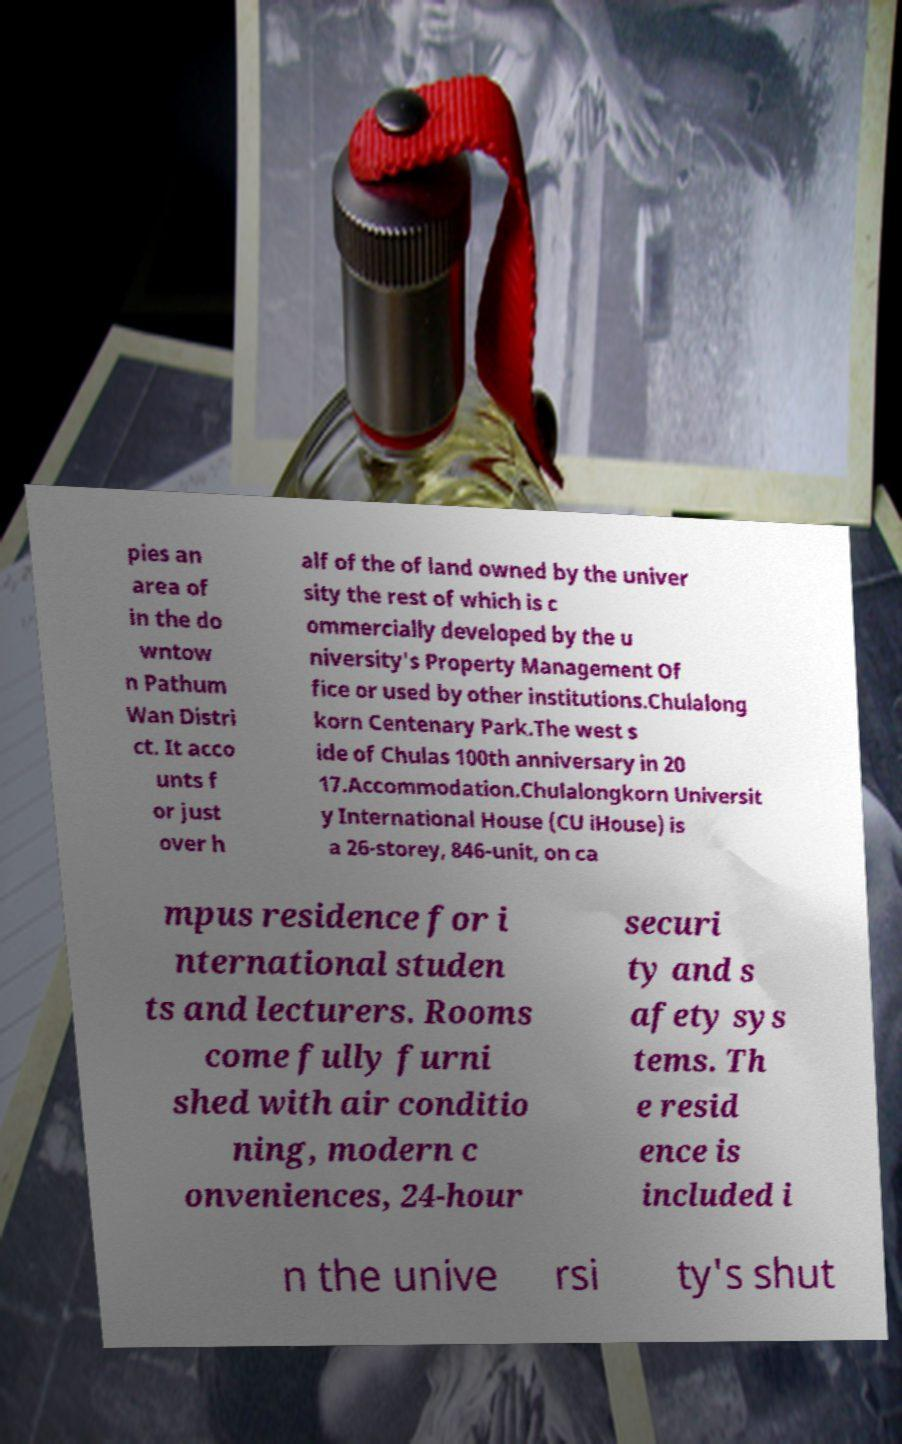Please identify and transcribe the text found in this image. pies an area of in the do wntow n Pathum Wan Distri ct. It acco unts f or just over h alf of the of land owned by the univer sity the rest of which is c ommercially developed by the u niversity's Property Management Of fice or used by other institutions.Chulalong korn Centenary Park.The west s ide of Chulas 100th anniversary in 20 17.Accommodation.Chulalongkorn Universit y International House (CU iHouse) is a 26-storey, 846-unit, on ca mpus residence for i nternational studen ts and lecturers. Rooms come fully furni shed with air conditio ning, modern c onveniences, 24-hour securi ty and s afety sys tems. Th e resid ence is included i n the unive rsi ty's shut 